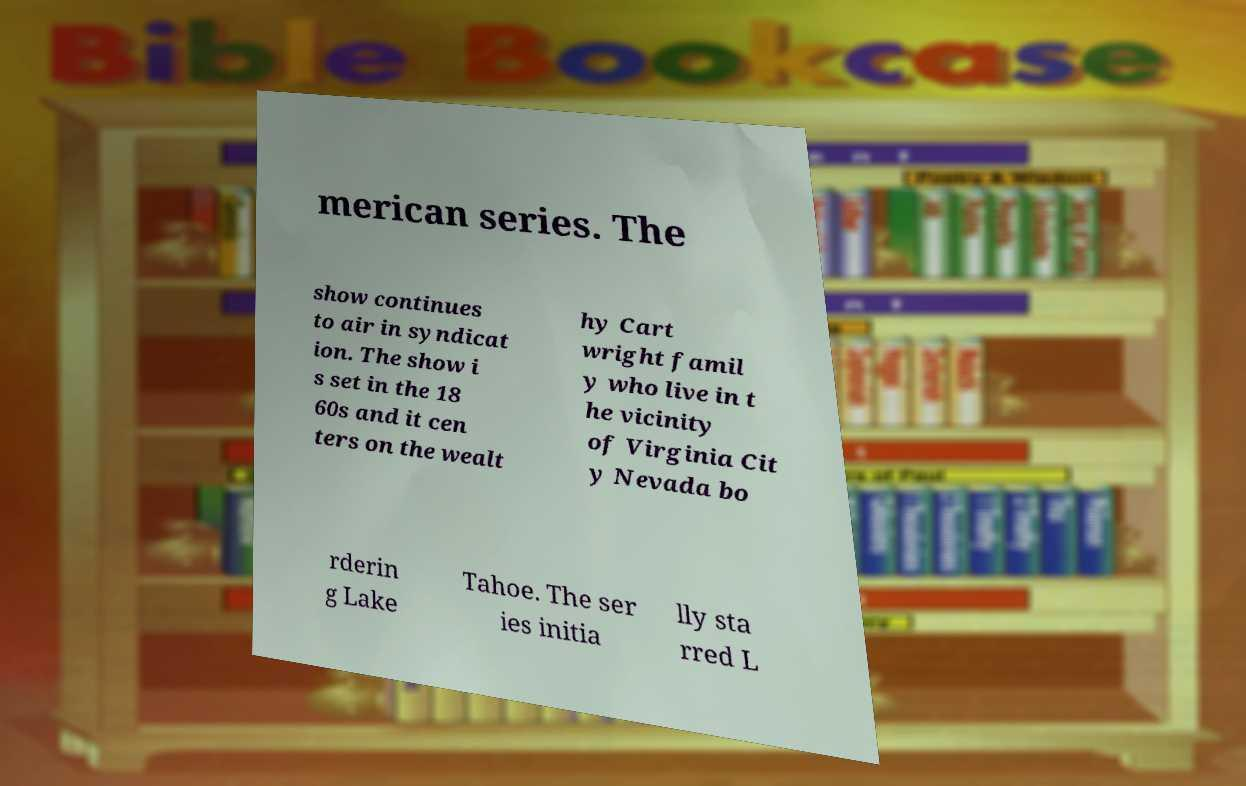For documentation purposes, I need the text within this image transcribed. Could you provide that? merican series. The show continues to air in syndicat ion. The show i s set in the 18 60s and it cen ters on the wealt hy Cart wright famil y who live in t he vicinity of Virginia Cit y Nevada bo rderin g Lake Tahoe. The ser ies initia lly sta rred L 